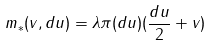Convert formula to latex. <formula><loc_0><loc_0><loc_500><loc_500>m _ { * } ( v , d u ) = \lambda \pi ( d u ) ( \frac { d u } { 2 } + v )</formula> 